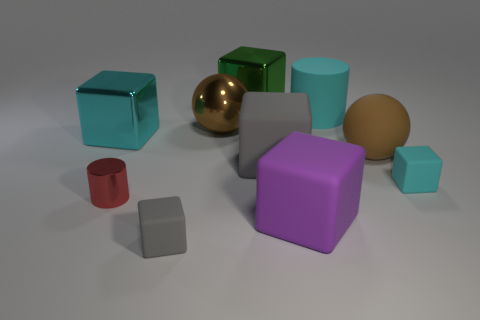Subtract 1 cubes. How many cubes are left? 5 Subtract all green cubes. How many cubes are left? 5 Subtract all green cubes. How many cubes are left? 5 Subtract all red cubes. Subtract all yellow balls. How many cubes are left? 6 Subtract all cylinders. How many objects are left? 8 Subtract 0 purple balls. How many objects are left? 10 Subtract all small purple matte spheres. Subtract all red metal cylinders. How many objects are left? 9 Add 3 metal balls. How many metal balls are left? 4 Add 6 big blue matte spheres. How many big blue matte spheres exist? 6 